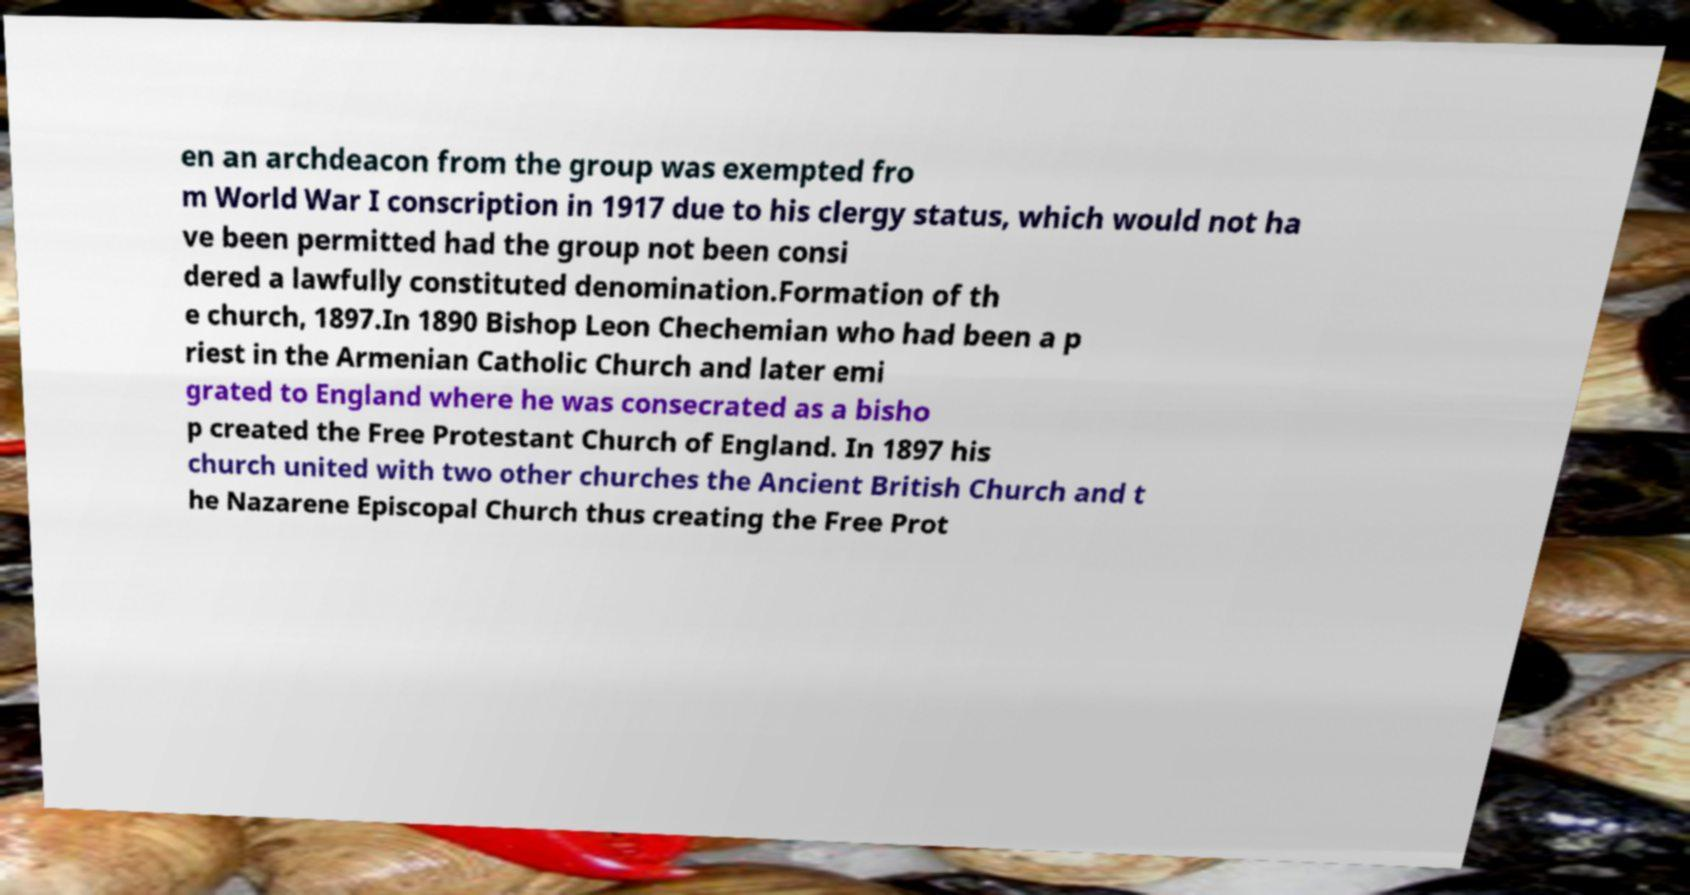I need the written content from this picture converted into text. Can you do that? en an archdeacon from the group was exempted fro m World War I conscription in 1917 due to his clergy status, which would not ha ve been permitted had the group not been consi dered a lawfully constituted denomination.Formation of th e church, 1897.In 1890 Bishop Leon Chechemian who had been a p riest in the Armenian Catholic Church and later emi grated to England where he was consecrated as a bisho p created the Free Protestant Church of England. In 1897 his church united with two other churches the Ancient British Church and t he Nazarene Episcopal Church thus creating the Free Prot 